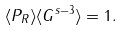<formula> <loc_0><loc_0><loc_500><loc_500>\langle P _ { R } \rangle \langle G ^ { s - 3 } \rangle = 1 .</formula> 